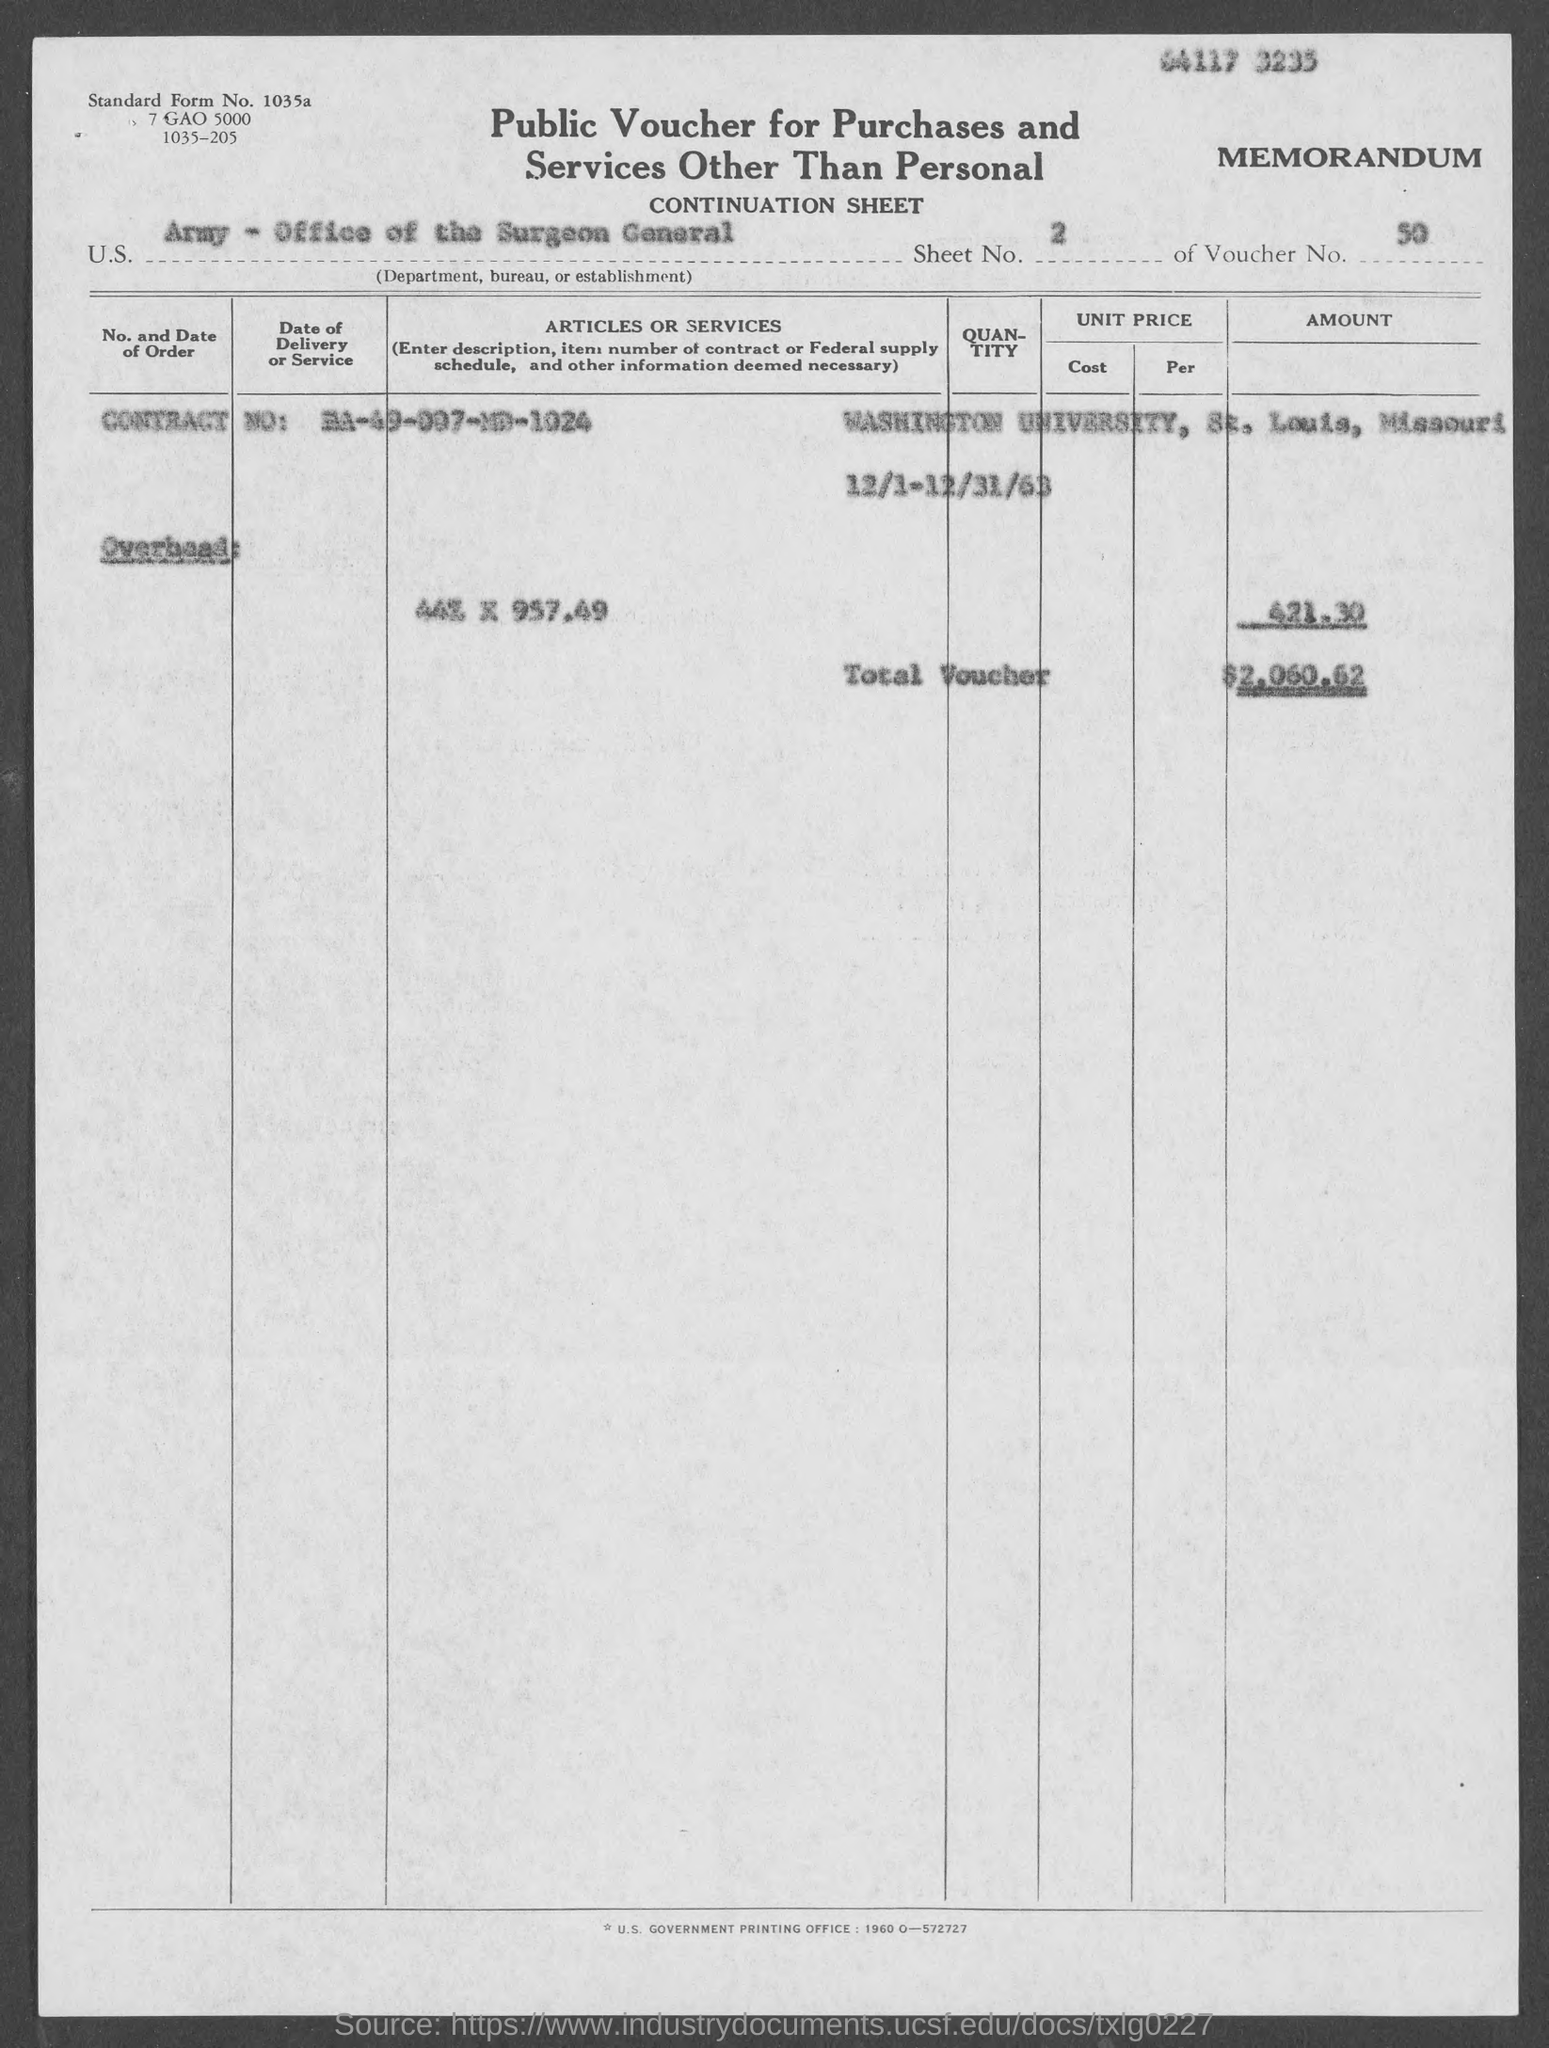What is the Standard Form No. given in the voucher?
Make the answer very short. 1035a. What type of voucher is given here?
Give a very brief answer. Public Voucher for Purchases and Services Other Than Personal. What is the U.S. Department, Bureau, or Establishment given in the voucher?
Give a very brief answer. Army - Office of the Surgeon General. What is the Sheet No. mentioned in the voucher?
Keep it short and to the point. 2. What is the voucher number given in the document?
Provide a succinct answer. 50. What is the Contract No. given in the voucher?
Make the answer very short. DA-49-007-MD-1024. What is the total voucher amount given in the document?
Provide a succinct answer. $2,060.62. 